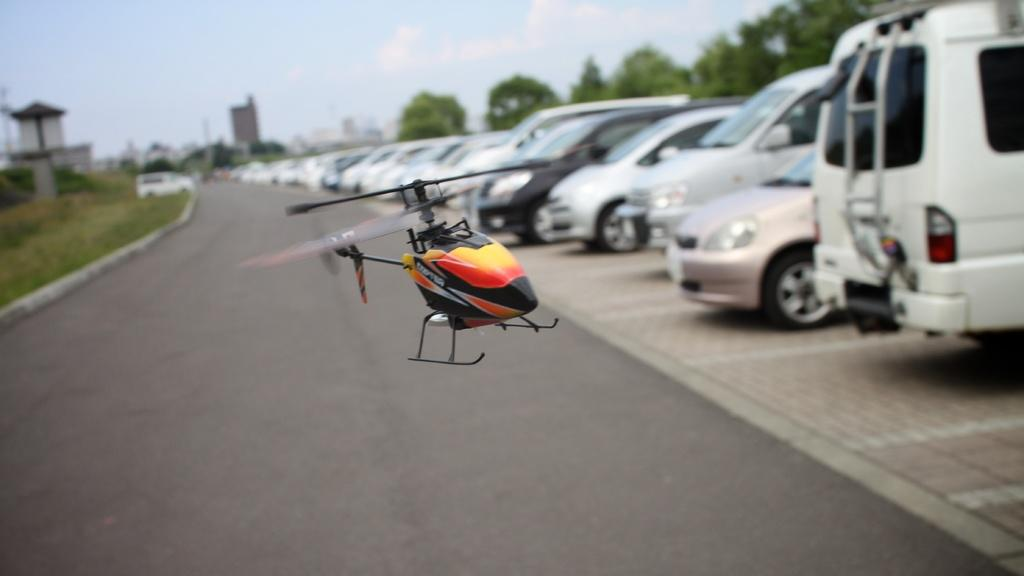What is the main subject in the center of the image? There is a helicopter rotor in the center of the image. What can be seen in the background of the image? There are cars, trees, and buildings in the background of the image. What type of vegetation is present on the left side of the image? There is grass on the ground on the left side of the image. What type of roof can be seen on the helicopter in the image? There is no helicopter present in the image, only a helicopter rotor. What color is the straw used to stir the helicopter rotor in the image? There is no straw present in the image, as the image only features a helicopter rotor and no other objects. 